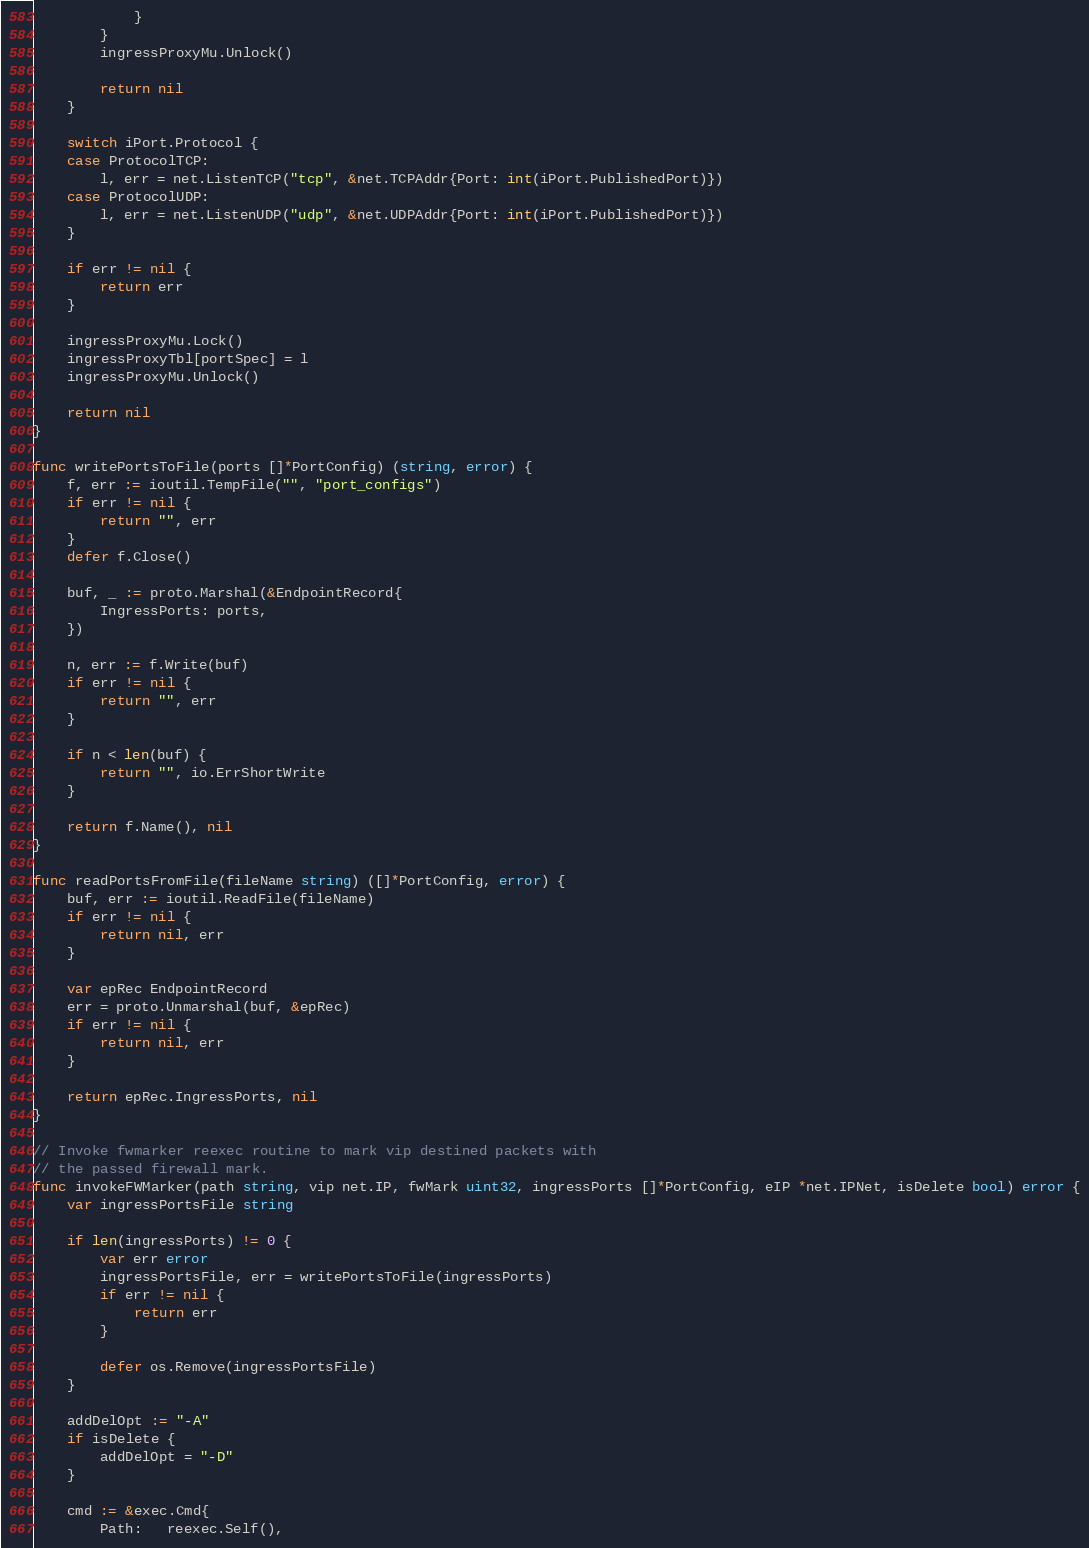<code> <loc_0><loc_0><loc_500><loc_500><_Go_>			}
		}
		ingressProxyMu.Unlock()

		return nil
	}

	switch iPort.Protocol {
	case ProtocolTCP:
		l, err = net.ListenTCP("tcp", &net.TCPAddr{Port: int(iPort.PublishedPort)})
	case ProtocolUDP:
		l, err = net.ListenUDP("udp", &net.UDPAddr{Port: int(iPort.PublishedPort)})
	}

	if err != nil {
		return err
	}

	ingressProxyMu.Lock()
	ingressProxyTbl[portSpec] = l
	ingressProxyMu.Unlock()

	return nil
}

func writePortsToFile(ports []*PortConfig) (string, error) {
	f, err := ioutil.TempFile("", "port_configs")
	if err != nil {
		return "", err
	}
	defer f.Close()

	buf, _ := proto.Marshal(&EndpointRecord{
		IngressPorts: ports,
	})

	n, err := f.Write(buf)
	if err != nil {
		return "", err
	}

	if n < len(buf) {
		return "", io.ErrShortWrite
	}

	return f.Name(), nil
}

func readPortsFromFile(fileName string) ([]*PortConfig, error) {
	buf, err := ioutil.ReadFile(fileName)
	if err != nil {
		return nil, err
	}

	var epRec EndpointRecord
	err = proto.Unmarshal(buf, &epRec)
	if err != nil {
		return nil, err
	}

	return epRec.IngressPorts, nil
}

// Invoke fwmarker reexec routine to mark vip destined packets with
// the passed firewall mark.
func invokeFWMarker(path string, vip net.IP, fwMark uint32, ingressPorts []*PortConfig, eIP *net.IPNet, isDelete bool) error {
	var ingressPortsFile string

	if len(ingressPorts) != 0 {
		var err error
		ingressPortsFile, err = writePortsToFile(ingressPorts)
		if err != nil {
			return err
		}

		defer os.Remove(ingressPortsFile)
	}

	addDelOpt := "-A"
	if isDelete {
		addDelOpt = "-D"
	}

	cmd := &exec.Cmd{
		Path:   reexec.Self(),</code> 